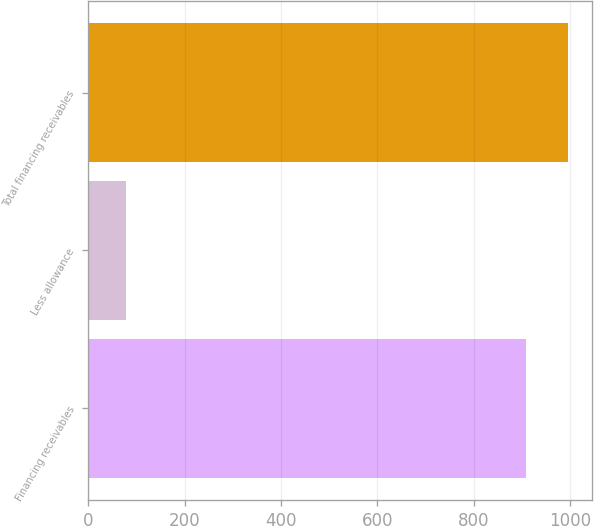Convert chart. <chart><loc_0><loc_0><loc_500><loc_500><bar_chart><fcel>Financing receivables<fcel>Less allowance<fcel>Total financing receivables<nl><fcel>908<fcel>79<fcel>995.1<nl></chart> 